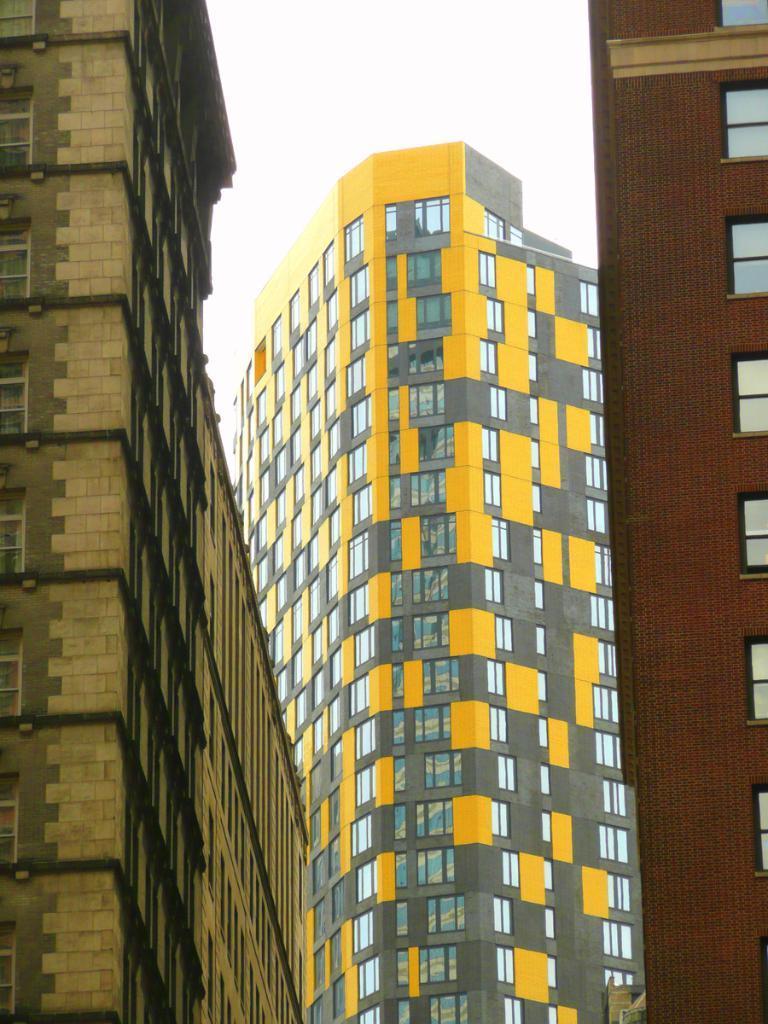Can you describe this image briefly? In the picture there are very tall buildings, they are having plenty of windows and there are total three buildings in the picture, in the background there is a sky. 